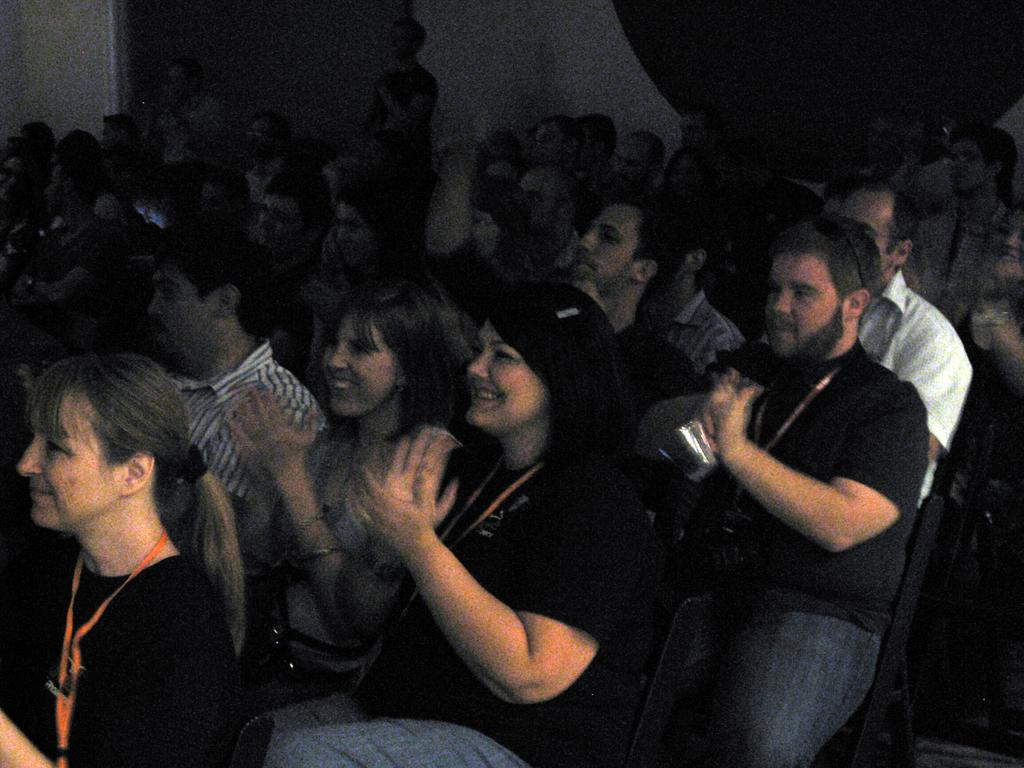What is happening in the image? There is a group of people in the image. How are the people positioned in the image? The people are sitting on chairs. What can be seen in the background of the image? There is a wall in the background of the image. What is the lighting condition in the image? The background is dark. What type of fuel is being used by the unit in the image? There is no unit or fuel present in the image; it features a group of people sitting on chairs with a wall in the background. 